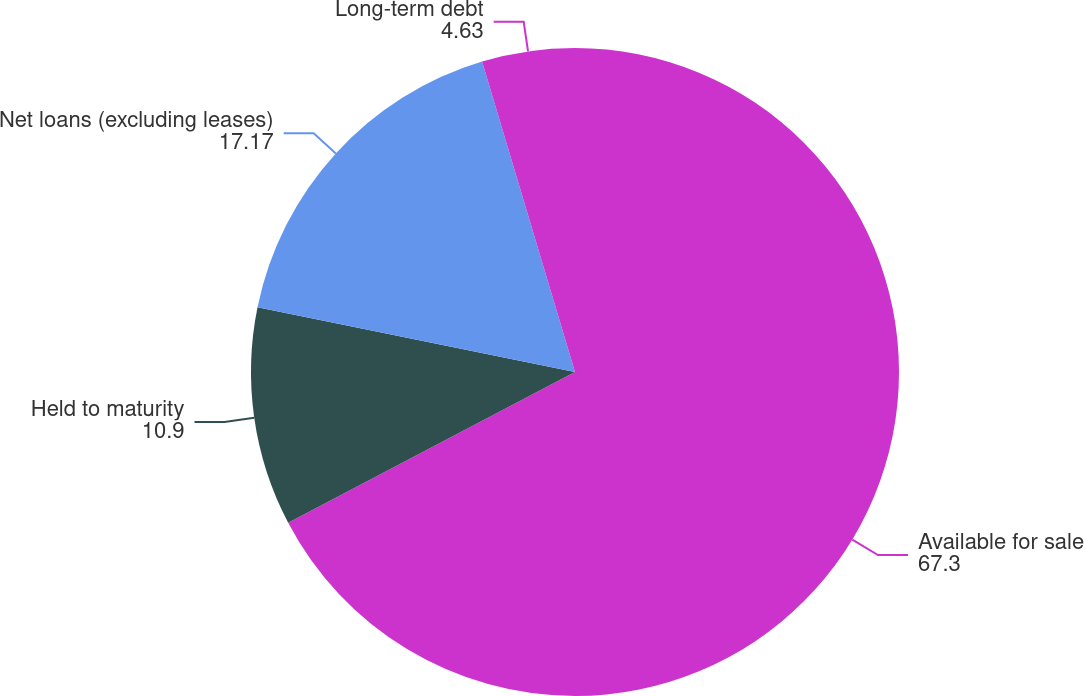<chart> <loc_0><loc_0><loc_500><loc_500><pie_chart><fcel>Available for sale<fcel>Held to maturity<fcel>Net loans (excluding leases)<fcel>Long-term debt<nl><fcel>67.3%<fcel>10.9%<fcel>17.17%<fcel>4.63%<nl></chart> 